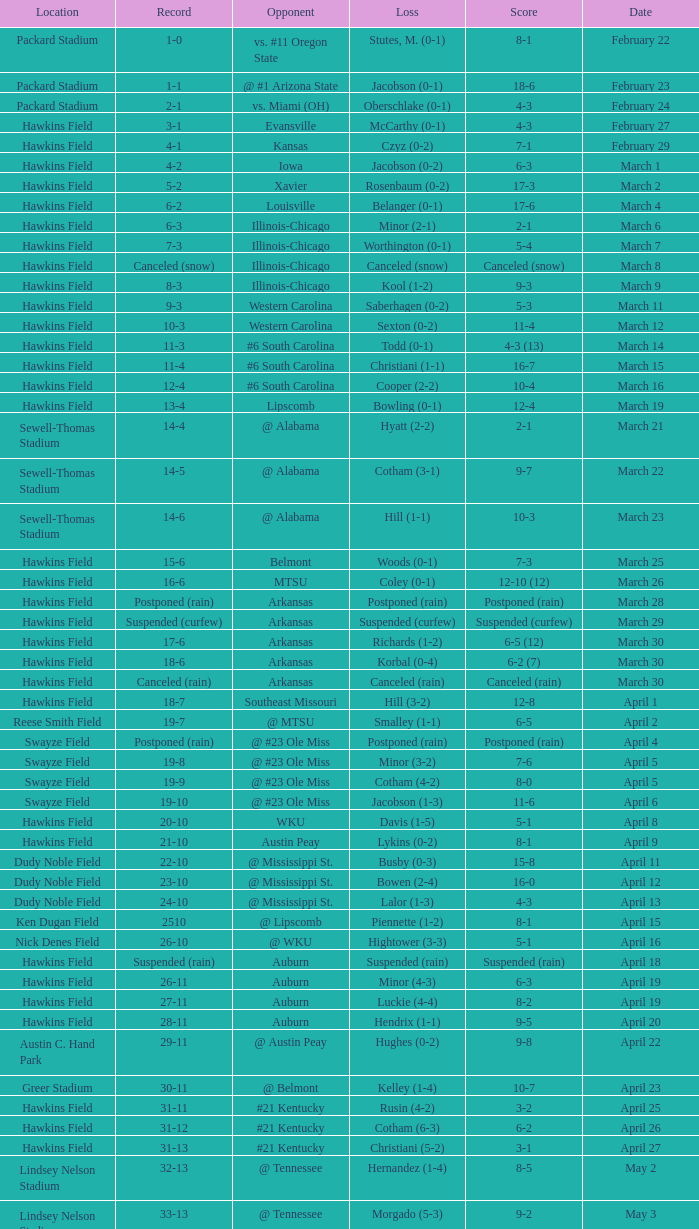What was the location of the game when the record was 12-4? Hawkins Field. 